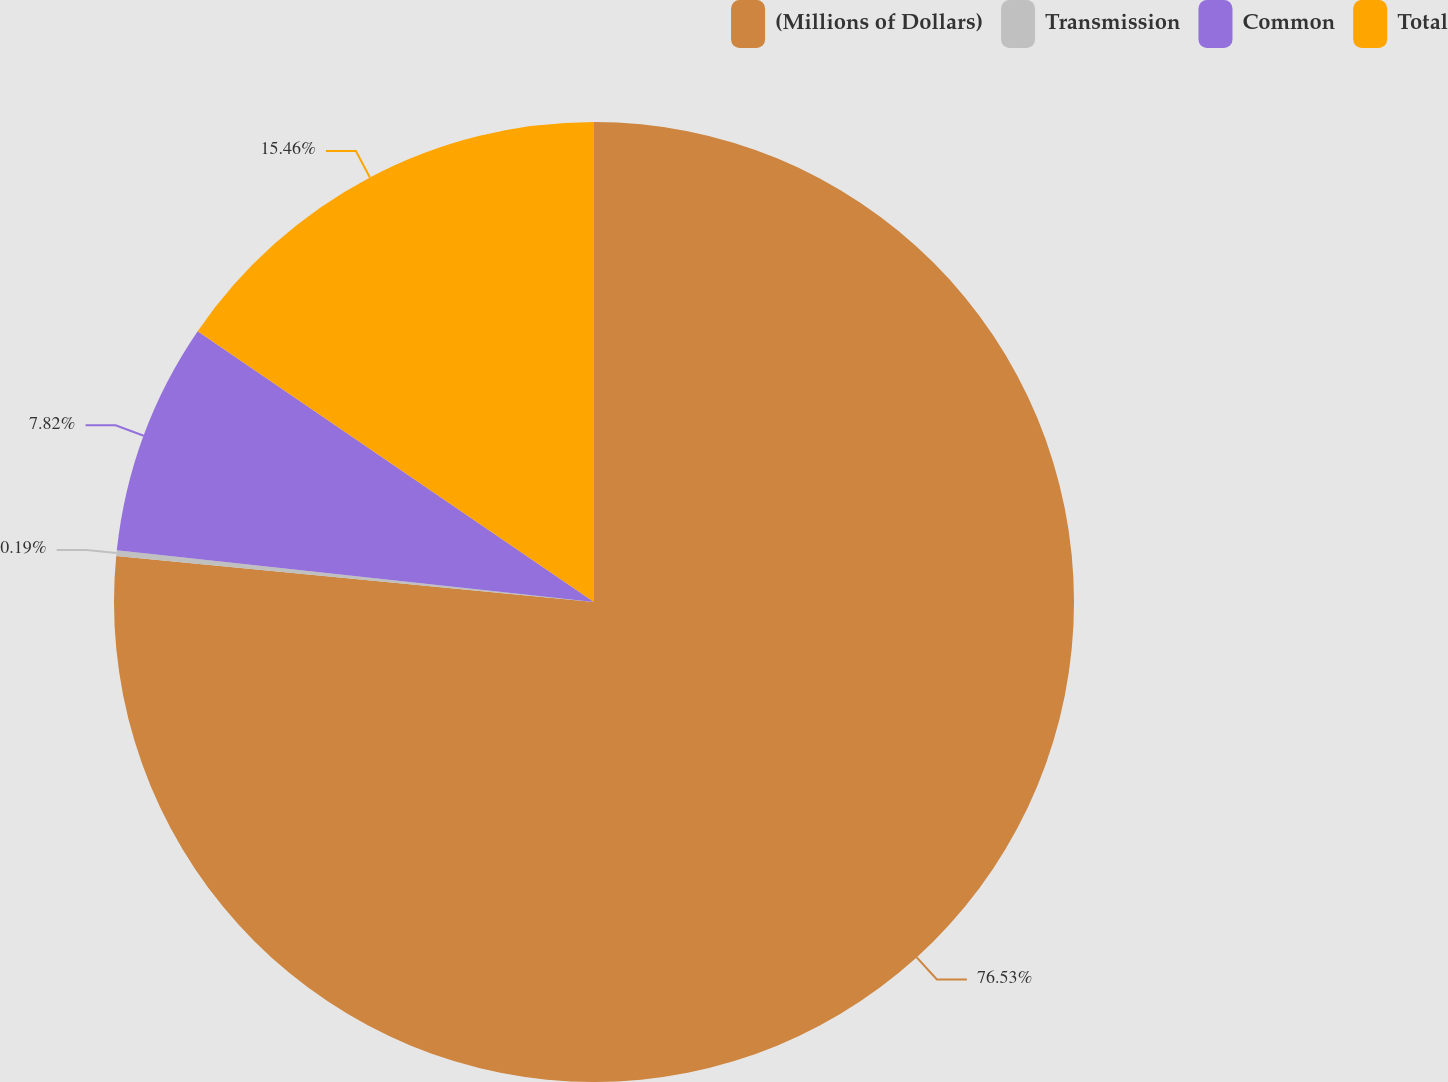Convert chart. <chart><loc_0><loc_0><loc_500><loc_500><pie_chart><fcel>(Millions of Dollars)<fcel>Transmission<fcel>Common<fcel>Total<nl><fcel>76.53%<fcel>0.19%<fcel>7.82%<fcel>15.46%<nl></chart> 